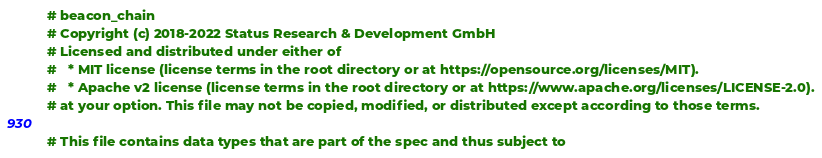Convert code to text. <code><loc_0><loc_0><loc_500><loc_500><_Nim_># beacon_chain
# Copyright (c) 2018-2022 Status Research & Development GmbH
# Licensed and distributed under either of
#   * MIT license (license terms in the root directory or at https://opensource.org/licenses/MIT).
#   * Apache v2 license (license terms in the root directory or at https://www.apache.org/licenses/LICENSE-2.0).
# at your option. This file may not be copied, modified, or distributed except according to those terms.

# This file contains data types that are part of the spec and thus subject to</code> 